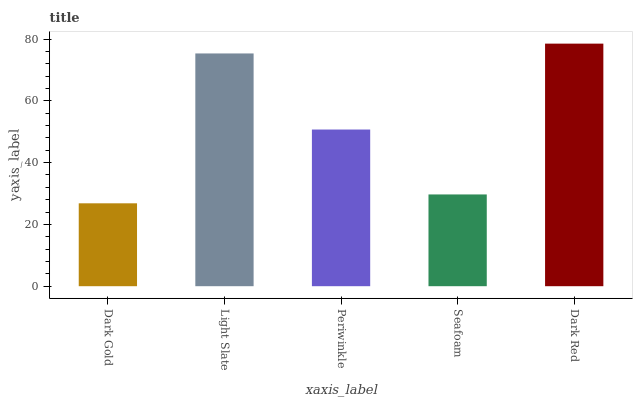Is Dark Gold the minimum?
Answer yes or no. Yes. Is Dark Red the maximum?
Answer yes or no. Yes. Is Light Slate the minimum?
Answer yes or no. No. Is Light Slate the maximum?
Answer yes or no. No. Is Light Slate greater than Dark Gold?
Answer yes or no. Yes. Is Dark Gold less than Light Slate?
Answer yes or no. Yes. Is Dark Gold greater than Light Slate?
Answer yes or no. No. Is Light Slate less than Dark Gold?
Answer yes or no. No. Is Periwinkle the high median?
Answer yes or no. Yes. Is Periwinkle the low median?
Answer yes or no. Yes. Is Dark Red the high median?
Answer yes or no. No. Is Dark Gold the low median?
Answer yes or no. No. 